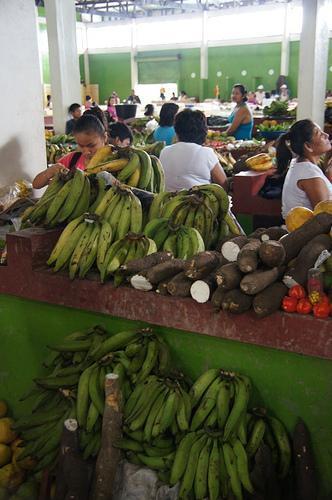How many people are wearing blue shirts?
Give a very brief answer. 2. How many white dots are on the wall?
Give a very brief answer. 4. 